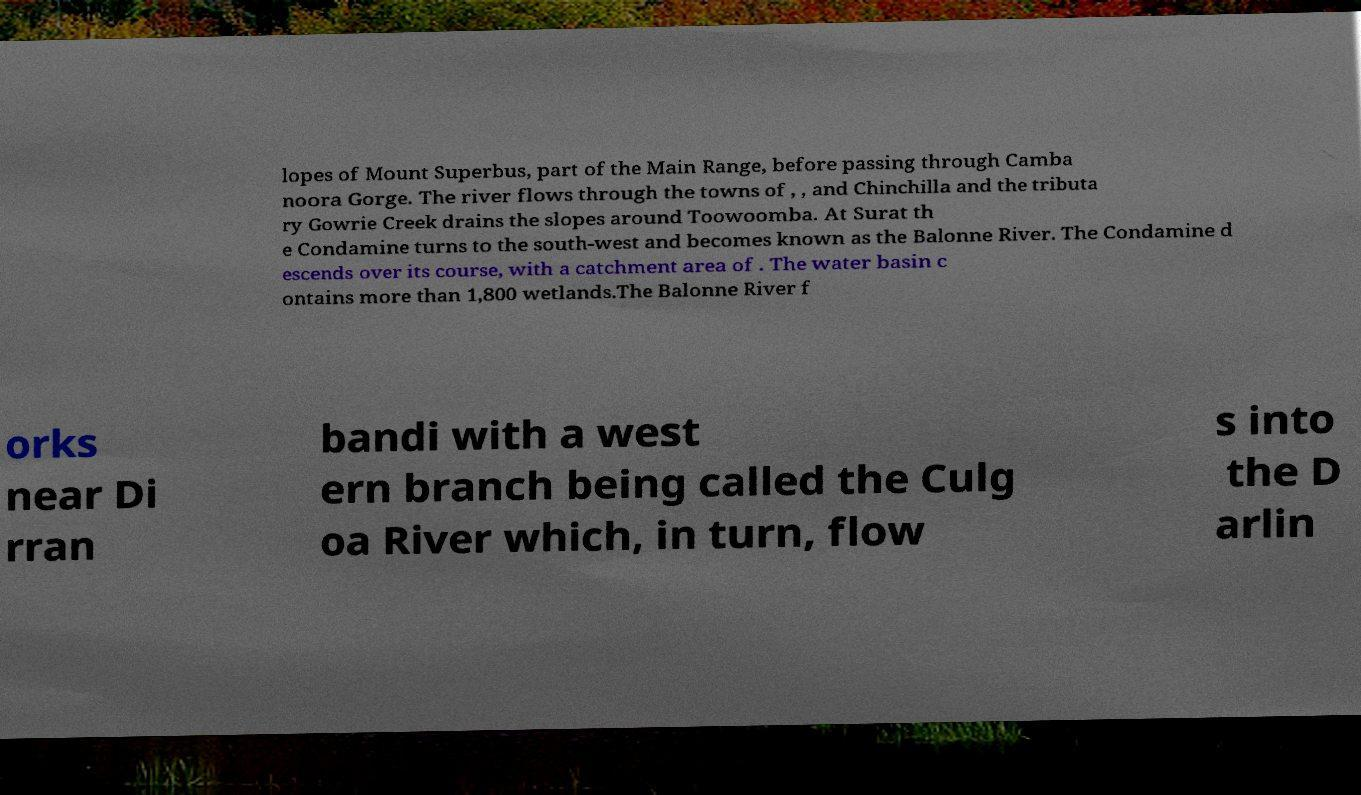Could you assist in decoding the text presented in this image and type it out clearly? lopes of Mount Superbus, part of the Main Range, before passing through Camba noora Gorge. The river flows through the towns of , , and Chinchilla and the tributa ry Gowrie Creek drains the slopes around Toowoomba. At Surat th e Condamine turns to the south-west and becomes known as the Balonne River. The Condamine d escends over its course, with a catchment area of . The water basin c ontains more than 1,800 wetlands.The Balonne River f orks near Di rran bandi with a west ern branch being called the Culg oa River which, in turn, flow s into the D arlin 